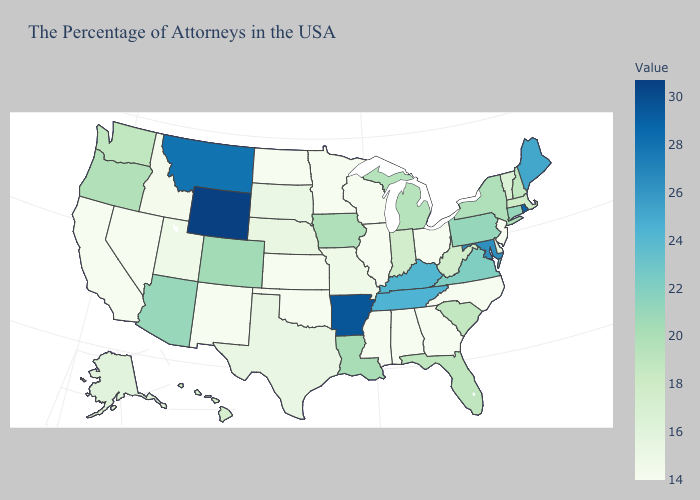Which states have the lowest value in the West?
Answer briefly. New Mexico, Nevada, California. Does Mississippi have the lowest value in the South?
Quick response, please. Yes. Among the states that border Oregon , does Nevada have the highest value?
Short answer required. No. Which states hav the highest value in the Northeast?
Write a very short answer. Rhode Island. Among the states that border Nevada , which have the highest value?
Keep it brief. Arizona. Among the states that border Montana , which have the highest value?
Write a very short answer. Wyoming. Among the states that border Illinois , which have the lowest value?
Be succinct. Wisconsin. 